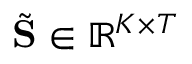Convert formula to latex. <formula><loc_0><loc_0><loc_500><loc_500>\tilde { S } \in \mathbb { R } ^ { K \times T }</formula> 